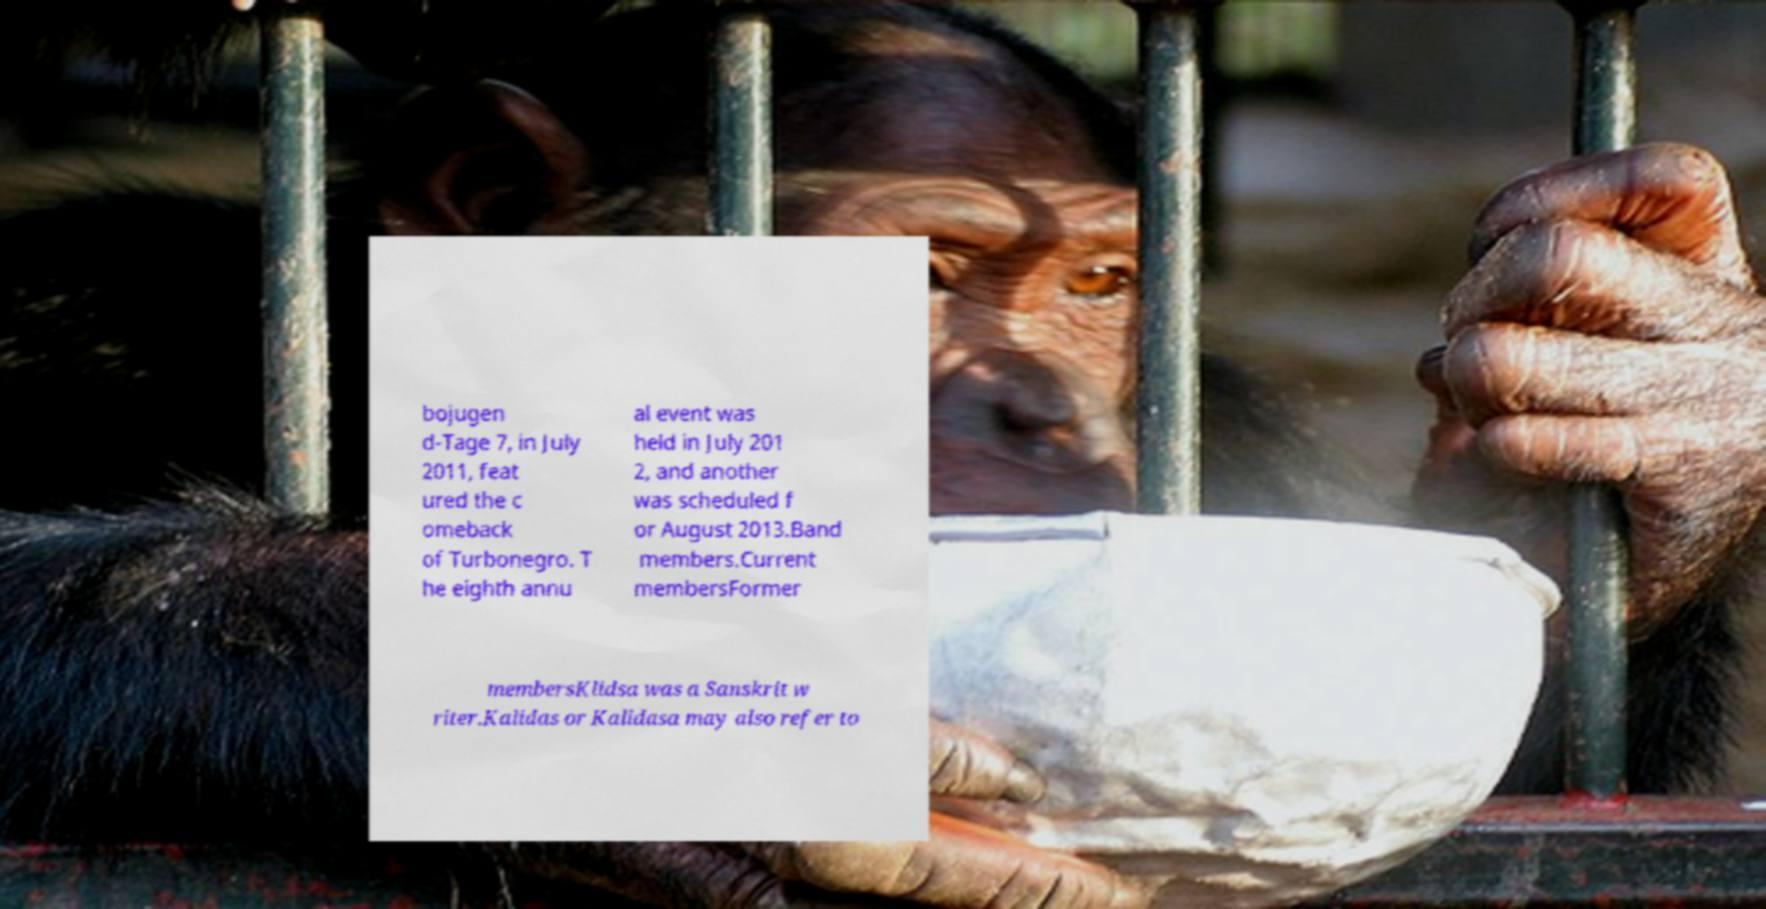I need the written content from this picture converted into text. Can you do that? bojugen d-Tage 7, in July 2011, feat ured the c omeback of Turbonegro. T he eighth annu al event was held in July 201 2, and another was scheduled f or August 2013.Band members.Current membersFormer membersKlidsa was a Sanskrit w riter.Kalidas or Kalidasa may also refer to 